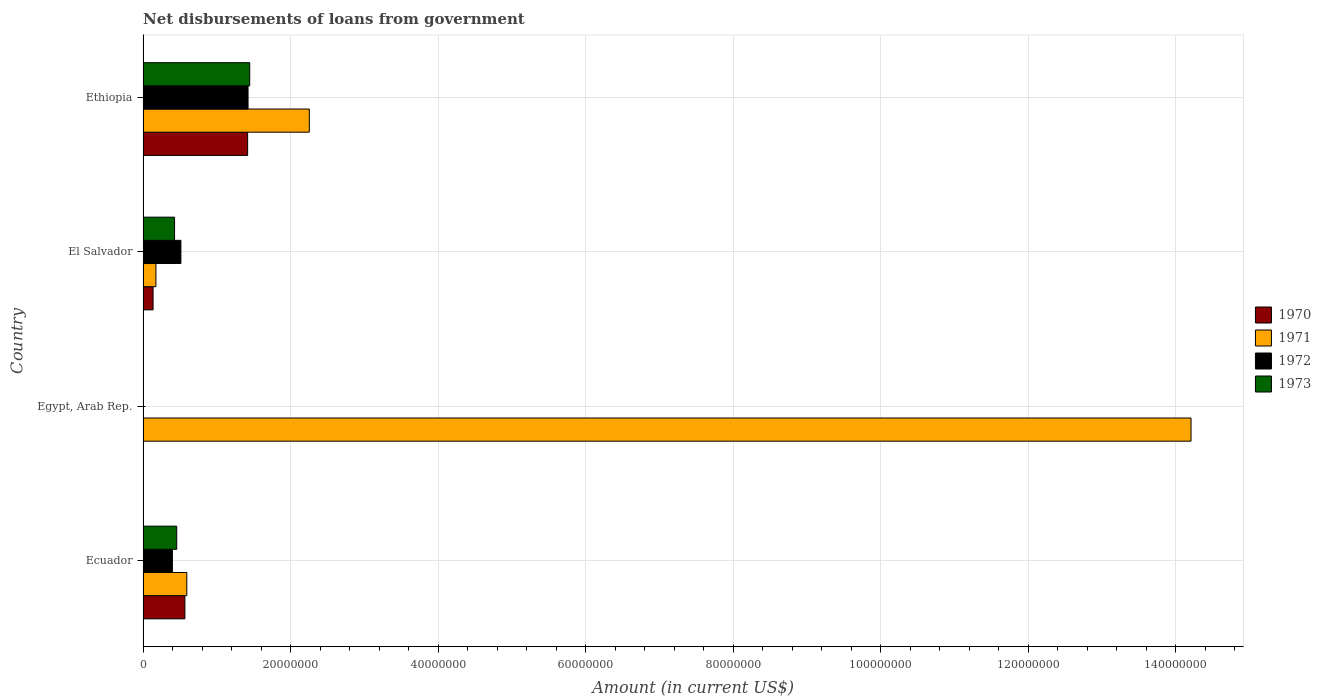How many different coloured bars are there?
Make the answer very short. 4. Are the number of bars per tick equal to the number of legend labels?
Your response must be concise. No. Are the number of bars on each tick of the Y-axis equal?
Make the answer very short. No. What is the label of the 1st group of bars from the top?
Keep it short and to the point. Ethiopia. What is the amount of loan disbursed from government in 1970 in El Salvador?
Ensure brevity in your answer.  1.36e+06. Across all countries, what is the maximum amount of loan disbursed from government in 1970?
Your answer should be compact. 1.42e+07. In which country was the amount of loan disbursed from government in 1971 maximum?
Your response must be concise. Egypt, Arab Rep. What is the total amount of loan disbursed from government in 1973 in the graph?
Keep it short and to the point. 2.33e+07. What is the difference between the amount of loan disbursed from government in 1971 in Ecuador and that in Egypt, Arab Rep.?
Offer a very short reply. -1.36e+08. What is the difference between the amount of loan disbursed from government in 1970 in Egypt, Arab Rep. and the amount of loan disbursed from government in 1971 in Ecuador?
Your answer should be very brief. -5.93e+06. What is the average amount of loan disbursed from government in 1971 per country?
Keep it short and to the point. 4.31e+07. What is the difference between the amount of loan disbursed from government in 1970 and amount of loan disbursed from government in 1973 in Ecuador?
Offer a very short reply. 1.11e+06. In how many countries, is the amount of loan disbursed from government in 1973 greater than 20000000 US$?
Provide a succinct answer. 0. What is the ratio of the amount of loan disbursed from government in 1972 in Ecuador to that in Ethiopia?
Make the answer very short. 0.28. Is the amount of loan disbursed from government in 1971 in El Salvador less than that in Ethiopia?
Keep it short and to the point. Yes. Is the difference between the amount of loan disbursed from government in 1970 in Ecuador and El Salvador greater than the difference between the amount of loan disbursed from government in 1973 in Ecuador and El Salvador?
Give a very brief answer. Yes. What is the difference between the highest and the second highest amount of loan disbursed from government in 1973?
Ensure brevity in your answer.  9.90e+06. What is the difference between the highest and the lowest amount of loan disbursed from government in 1973?
Give a very brief answer. 1.45e+07. Is it the case that in every country, the sum of the amount of loan disbursed from government in 1972 and amount of loan disbursed from government in 1970 is greater than the amount of loan disbursed from government in 1971?
Make the answer very short. No. How many bars are there?
Offer a very short reply. 13. Does the graph contain any zero values?
Provide a succinct answer. Yes. Where does the legend appear in the graph?
Ensure brevity in your answer.  Center right. How are the legend labels stacked?
Offer a very short reply. Vertical. What is the title of the graph?
Provide a succinct answer. Net disbursements of loans from government. Does "1987" appear as one of the legend labels in the graph?
Give a very brief answer. No. What is the label or title of the X-axis?
Provide a short and direct response. Amount (in current US$). What is the label or title of the Y-axis?
Make the answer very short. Country. What is the Amount (in current US$) in 1970 in Ecuador?
Offer a terse response. 5.67e+06. What is the Amount (in current US$) of 1971 in Ecuador?
Offer a very short reply. 5.93e+06. What is the Amount (in current US$) in 1972 in Ecuador?
Keep it short and to the point. 3.98e+06. What is the Amount (in current US$) in 1973 in Ecuador?
Offer a terse response. 4.56e+06. What is the Amount (in current US$) in 1971 in Egypt, Arab Rep.?
Give a very brief answer. 1.42e+08. What is the Amount (in current US$) of 1972 in Egypt, Arab Rep.?
Your answer should be compact. 0. What is the Amount (in current US$) in 1970 in El Salvador?
Your response must be concise. 1.36e+06. What is the Amount (in current US$) in 1971 in El Salvador?
Give a very brief answer. 1.74e+06. What is the Amount (in current US$) in 1972 in El Salvador?
Your response must be concise. 5.13e+06. What is the Amount (in current US$) of 1973 in El Salvador?
Keep it short and to the point. 4.27e+06. What is the Amount (in current US$) in 1970 in Ethiopia?
Your response must be concise. 1.42e+07. What is the Amount (in current US$) of 1971 in Ethiopia?
Provide a succinct answer. 2.25e+07. What is the Amount (in current US$) in 1972 in Ethiopia?
Ensure brevity in your answer.  1.42e+07. What is the Amount (in current US$) of 1973 in Ethiopia?
Your answer should be compact. 1.45e+07. Across all countries, what is the maximum Amount (in current US$) in 1970?
Your answer should be compact. 1.42e+07. Across all countries, what is the maximum Amount (in current US$) of 1971?
Provide a succinct answer. 1.42e+08. Across all countries, what is the maximum Amount (in current US$) of 1972?
Provide a succinct answer. 1.42e+07. Across all countries, what is the maximum Amount (in current US$) of 1973?
Provide a short and direct response. 1.45e+07. Across all countries, what is the minimum Amount (in current US$) in 1970?
Give a very brief answer. 0. Across all countries, what is the minimum Amount (in current US$) in 1971?
Provide a short and direct response. 1.74e+06. Across all countries, what is the minimum Amount (in current US$) of 1973?
Your answer should be compact. 0. What is the total Amount (in current US$) in 1970 in the graph?
Make the answer very short. 2.12e+07. What is the total Amount (in current US$) of 1971 in the graph?
Keep it short and to the point. 1.72e+08. What is the total Amount (in current US$) of 1972 in the graph?
Provide a succinct answer. 2.33e+07. What is the total Amount (in current US$) in 1973 in the graph?
Give a very brief answer. 2.33e+07. What is the difference between the Amount (in current US$) of 1971 in Ecuador and that in Egypt, Arab Rep.?
Your response must be concise. -1.36e+08. What is the difference between the Amount (in current US$) in 1970 in Ecuador and that in El Salvador?
Keep it short and to the point. 4.32e+06. What is the difference between the Amount (in current US$) of 1971 in Ecuador and that in El Salvador?
Provide a succinct answer. 4.19e+06. What is the difference between the Amount (in current US$) in 1972 in Ecuador and that in El Salvador?
Your response must be concise. -1.15e+06. What is the difference between the Amount (in current US$) of 1973 in Ecuador and that in El Salvador?
Offer a very short reply. 2.91e+05. What is the difference between the Amount (in current US$) in 1970 in Ecuador and that in Ethiopia?
Give a very brief answer. -8.50e+06. What is the difference between the Amount (in current US$) of 1971 in Ecuador and that in Ethiopia?
Your answer should be compact. -1.66e+07. What is the difference between the Amount (in current US$) in 1972 in Ecuador and that in Ethiopia?
Your answer should be compact. -1.03e+07. What is the difference between the Amount (in current US$) of 1973 in Ecuador and that in Ethiopia?
Offer a terse response. -9.90e+06. What is the difference between the Amount (in current US$) in 1971 in Egypt, Arab Rep. and that in El Salvador?
Your answer should be very brief. 1.40e+08. What is the difference between the Amount (in current US$) of 1971 in Egypt, Arab Rep. and that in Ethiopia?
Offer a very short reply. 1.20e+08. What is the difference between the Amount (in current US$) in 1970 in El Salvador and that in Ethiopia?
Give a very brief answer. -1.28e+07. What is the difference between the Amount (in current US$) in 1971 in El Salvador and that in Ethiopia?
Offer a very short reply. -2.08e+07. What is the difference between the Amount (in current US$) of 1972 in El Salvador and that in Ethiopia?
Give a very brief answer. -9.10e+06. What is the difference between the Amount (in current US$) of 1973 in El Salvador and that in Ethiopia?
Keep it short and to the point. -1.02e+07. What is the difference between the Amount (in current US$) in 1970 in Ecuador and the Amount (in current US$) in 1971 in Egypt, Arab Rep.?
Offer a terse response. -1.36e+08. What is the difference between the Amount (in current US$) in 1970 in Ecuador and the Amount (in current US$) in 1971 in El Salvador?
Keep it short and to the point. 3.93e+06. What is the difference between the Amount (in current US$) of 1970 in Ecuador and the Amount (in current US$) of 1972 in El Salvador?
Keep it short and to the point. 5.42e+05. What is the difference between the Amount (in current US$) of 1970 in Ecuador and the Amount (in current US$) of 1973 in El Salvador?
Your response must be concise. 1.40e+06. What is the difference between the Amount (in current US$) of 1971 in Ecuador and the Amount (in current US$) of 1972 in El Salvador?
Your answer should be compact. 8.02e+05. What is the difference between the Amount (in current US$) of 1971 in Ecuador and the Amount (in current US$) of 1973 in El Salvador?
Your answer should be very brief. 1.66e+06. What is the difference between the Amount (in current US$) in 1972 in Ecuador and the Amount (in current US$) in 1973 in El Salvador?
Your answer should be compact. -2.93e+05. What is the difference between the Amount (in current US$) of 1970 in Ecuador and the Amount (in current US$) of 1971 in Ethiopia?
Your response must be concise. -1.69e+07. What is the difference between the Amount (in current US$) in 1970 in Ecuador and the Amount (in current US$) in 1972 in Ethiopia?
Your response must be concise. -8.56e+06. What is the difference between the Amount (in current US$) in 1970 in Ecuador and the Amount (in current US$) in 1973 in Ethiopia?
Your answer should be very brief. -8.79e+06. What is the difference between the Amount (in current US$) of 1971 in Ecuador and the Amount (in current US$) of 1972 in Ethiopia?
Your answer should be very brief. -8.30e+06. What is the difference between the Amount (in current US$) of 1971 in Ecuador and the Amount (in current US$) of 1973 in Ethiopia?
Keep it short and to the point. -8.53e+06. What is the difference between the Amount (in current US$) in 1972 in Ecuador and the Amount (in current US$) in 1973 in Ethiopia?
Your answer should be compact. -1.05e+07. What is the difference between the Amount (in current US$) of 1971 in Egypt, Arab Rep. and the Amount (in current US$) of 1972 in El Salvador?
Offer a very short reply. 1.37e+08. What is the difference between the Amount (in current US$) of 1971 in Egypt, Arab Rep. and the Amount (in current US$) of 1973 in El Salvador?
Make the answer very short. 1.38e+08. What is the difference between the Amount (in current US$) of 1971 in Egypt, Arab Rep. and the Amount (in current US$) of 1972 in Ethiopia?
Give a very brief answer. 1.28e+08. What is the difference between the Amount (in current US$) in 1971 in Egypt, Arab Rep. and the Amount (in current US$) in 1973 in Ethiopia?
Ensure brevity in your answer.  1.28e+08. What is the difference between the Amount (in current US$) in 1970 in El Salvador and the Amount (in current US$) in 1971 in Ethiopia?
Offer a terse response. -2.12e+07. What is the difference between the Amount (in current US$) in 1970 in El Salvador and the Amount (in current US$) in 1972 in Ethiopia?
Ensure brevity in your answer.  -1.29e+07. What is the difference between the Amount (in current US$) of 1970 in El Salvador and the Amount (in current US$) of 1973 in Ethiopia?
Your answer should be very brief. -1.31e+07. What is the difference between the Amount (in current US$) of 1971 in El Salvador and the Amount (in current US$) of 1972 in Ethiopia?
Ensure brevity in your answer.  -1.25e+07. What is the difference between the Amount (in current US$) in 1971 in El Salvador and the Amount (in current US$) in 1973 in Ethiopia?
Your answer should be compact. -1.27e+07. What is the difference between the Amount (in current US$) in 1972 in El Salvador and the Amount (in current US$) in 1973 in Ethiopia?
Your answer should be compact. -9.33e+06. What is the average Amount (in current US$) in 1970 per country?
Provide a succinct answer. 5.30e+06. What is the average Amount (in current US$) in 1971 per country?
Your response must be concise. 4.31e+07. What is the average Amount (in current US$) in 1972 per country?
Your answer should be very brief. 5.84e+06. What is the average Amount (in current US$) in 1973 per country?
Offer a very short reply. 5.82e+06. What is the difference between the Amount (in current US$) of 1970 and Amount (in current US$) of 1972 in Ecuador?
Offer a very short reply. 1.69e+06. What is the difference between the Amount (in current US$) of 1970 and Amount (in current US$) of 1973 in Ecuador?
Your response must be concise. 1.11e+06. What is the difference between the Amount (in current US$) in 1971 and Amount (in current US$) in 1972 in Ecuador?
Make the answer very short. 1.95e+06. What is the difference between the Amount (in current US$) of 1971 and Amount (in current US$) of 1973 in Ecuador?
Offer a very short reply. 1.37e+06. What is the difference between the Amount (in current US$) of 1972 and Amount (in current US$) of 1973 in Ecuador?
Ensure brevity in your answer.  -5.84e+05. What is the difference between the Amount (in current US$) in 1970 and Amount (in current US$) in 1971 in El Salvador?
Provide a short and direct response. -3.88e+05. What is the difference between the Amount (in current US$) in 1970 and Amount (in current US$) in 1972 in El Salvador?
Provide a short and direct response. -3.77e+06. What is the difference between the Amount (in current US$) in 1970 and Amount (in current US$) in 1973 in El Salvador?
Your answer should be compact. -2.92e+06. What is the difference between the Amount (in current US$) in 1971 and Amount (in current US$) in 1972 in El Salvador?
Offer a terse response. -3.39e+06. What is the difference between the Amount (in current US$) in 1971 and Amount (in current US$) in 1973 in El Salvador?
Make the answer very short. -2.53e+06. What is the difference between the Amount (in current US$) in 1972 and Amount (in current US$) in 1973 in El Salvador?
Keep it short and to the point. 8.59e+05. What is the difference between the Amount (in current US$) in 1970 and Amount (in current US$) in 1971 in Ethiopia?
Your answer should be very brief. -8.36e+06. What is the difference between the Amount (in current US$) of 1970 and Amount (in current US$) of 1972 in Ethiopia?
Give a very brief answer. -5.80e+04. What is the difference between the Amount (in current US$) of 1970 and Amount (in current US$) of 1973 in Ethiopia?
Provide a short and direct response. -2.85e+05. What is the difference between the Amount (in current US$) of 1971 and Amount (in current US$) of 1972 in Ethiopia?
Your answer should be very brief. 8.31e+06. What is the difference between the Amount (in current US$) of 1971 and Amount (in current US$) of 1973 in Ethiopia?
Give a very brief answer. 8.08e+06. What is the difference between the Amount (in current US$) in 1972 and Amount (in current US$) in 1973 in Ethiopia?
Give a very brief answer. -2.27e+05. What is the ratio of the Amount (in current US$) of 1971 in Ecuador to that in Egypt, Arab Rep.?
Your answer should be compact. 0.04. What is the ratio of the Amount (in current US$) of 1970 in Ecuador to that in El Salvador?
Offer a terse response. 4.18. What is the ratio of the Amount (in current US$) of 1971 in Ecuador to that in El Salvador?
Your answer should be very brief. 3.4. What is the ratio of the Amount (in current US$) in 1972 in Ecuador to that in El Salvador?
Make the answer very short. 0.78. What is the ratio of the Amount (in current US$) in 1973 in Ecuador to that in El Salvador?
Make the answer very short. 1.07. What is the ratio of the Amount (in current US$) in 1970 in Ecuador to that in Ethiopia?
Give a very brief answer. 0.4. What is the ratio of the Amount (in current US$) in 1971 in Ecuador to that in Ethiopia?
Offer a terse response. 0.26. What is the ratio of the Amount (in current US$) in 1972 in Ecuador to that in Ethiopia?
Offer a terse response. 0.28. What is the ratio of the Amount (in current US$) in 1973 in Ecuador to that in Ethiopia?
Offer a very short reply. 0.32. What is the ratio of the Amount (in current US$) of 1971 in Egypt, Arab Rep. to that in El Salvador?
Give a very brief answer. 81.43. What is the ratio of the Amount (in current US$) in 1971 in Egypt, Arab Rep. to that in Ethiopia?
Your answer should be compact. 6.3. What is the ratio of the Amount (in current US$) of 1970 in El Salvador to that in Ethiopia?
Provide a succinct answer. 0.1. What is the ratio of the Amount (in current US$) in 1971 in El Salvador to that in Ethiopia?
Ensure brevity in your answer.  0.08. What is the ratio of the Amount (in current US$) in 1972 in El Salvador to that in Ethiopia?
Provide a short and direct response. 0.36. What is the ratio of the Amount (in current US$) of 1973 in El Salvador to that in Ethiopia?
Your answer should be very brief. 0.3. What is the difference between the highest and the second highest Amount (in current US$) in 1970?
Ensure brevity in your answer.  8.50e+06. What is the difference between the highest and the second highest Amount (in current US$) of 1971?
Offer a terse response. 1.20e+08. What is the difference between the highest and the second highest Amount (in current US$) of 1972?
Give a very brief answer. 9.10e+06. What is the difference between the highest and the second highest Amount (in current US$) in 1973?
Ensure brevity in your answer.  9.90e+06. What is the difference between the highest and the lowest Amount (in current US$) in 1970?
Provide a succinct answer. 1.42e+07. What is the difference between the highest and the lowest Amount (in current US$) of 1971?
Your response must be concise. 1.40e+08. What is the difference between the highest and the lowest Amount (in current US$) in 1972?
Keep it short and to the point. 1.42e+07. What is the difference between the highest and the lowest Amount (in current US$) in 1973?
Keep it short and to the point. 1.45e+07. 